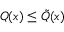<formula> <loc_0><loc_0><loc_500><loc_500>Q ( x ) \leq { \tilde { Q } } ( x )</formula> 